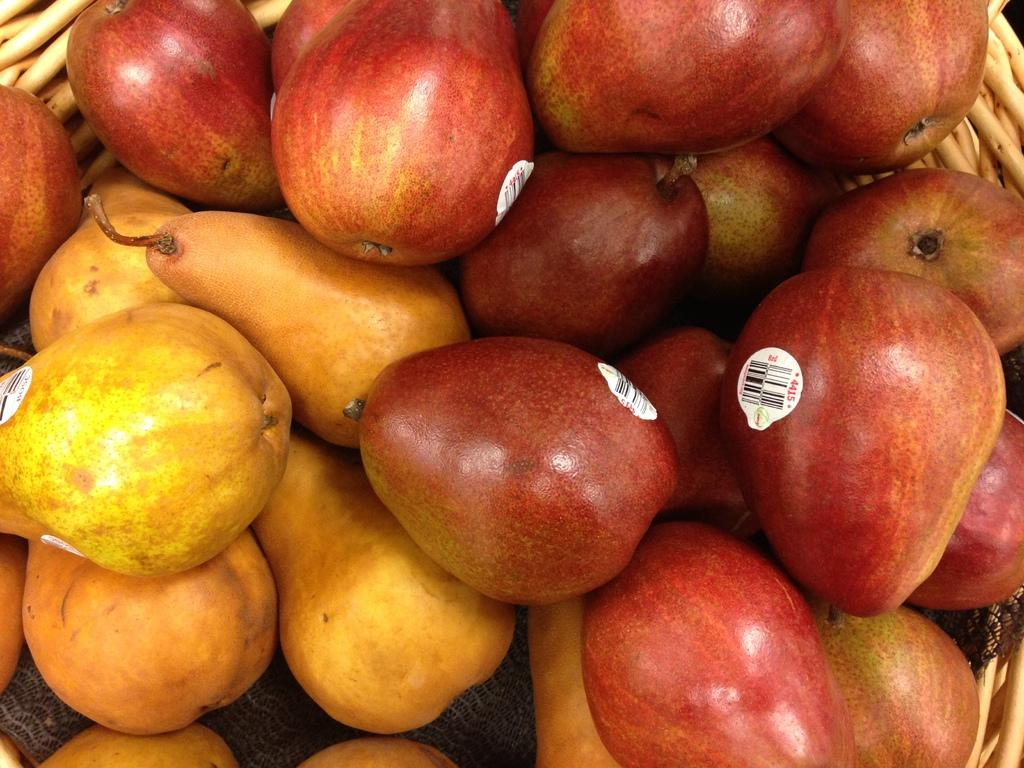What type of food can be seen in the image? There are fruits in the image. Which specific fruit is included in the image? The fruits include apples. How can you identify the apples in the image? The apples have stickers on them. How are the fruits arranged in the image? The fruits are placed in a basket. What season is being taught in the image? There is no indication of teaching or a specific season in the image; it simply shows fruits in a basket. 